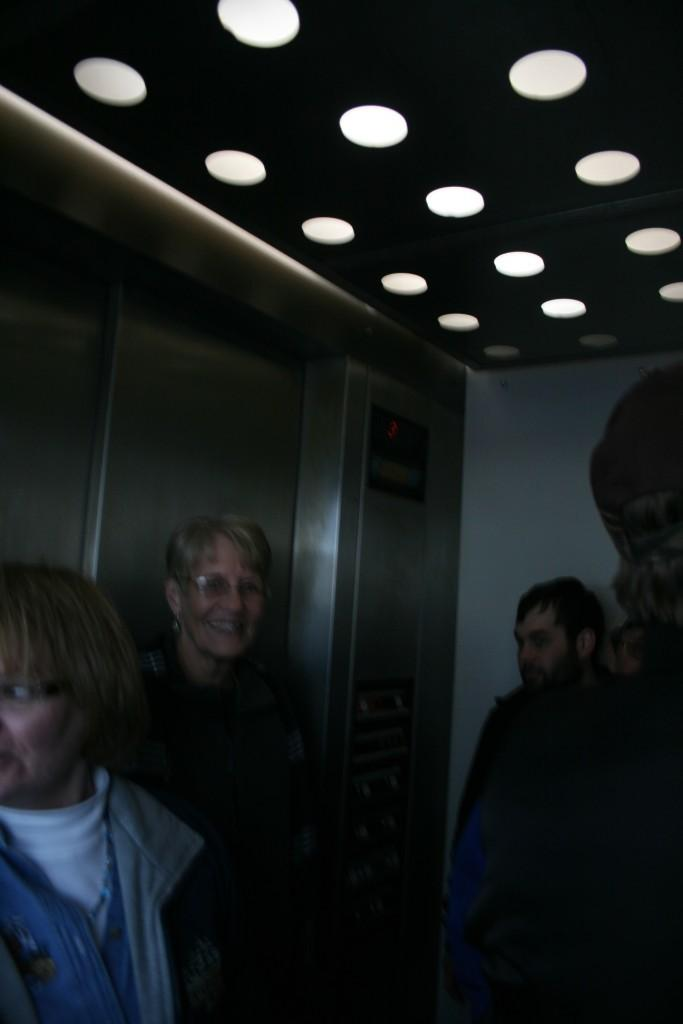What is the main object in the image? There is a lift in the image. Who or what is inside the lift? There are people inside the lift. What can be seen on top of the image? There are lights on top of the image. Can you describe the woman in the background of the image? A woman is visible in the background of the image, and she is smiling. Where is the faucet located in the image? There is no faucet present in the image. What type of blade is being used by the woman in the image? There is no blade present in the image, and the woman is not using any tool or object. 